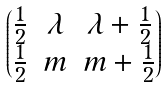Convert formula to latex. <formula><loc_0><loc_0><loc_500><loc_500>\begin{pmatrix} \frac { 1 } { 2 } & \lambda & \lambda + \frac { 1 } { 2 } \\ \frac { 1 } { 2 } & m & m + \frac { 1 } { 2 } \end{pmatrix}</formula> 